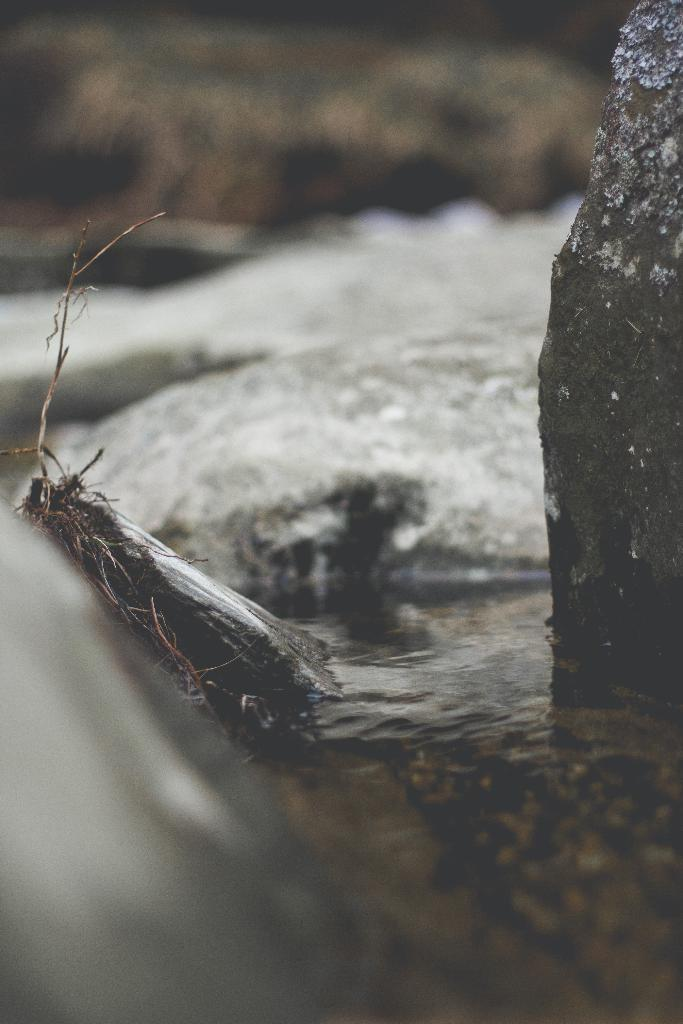What is present in the image that is not solid? There is water in the image. What solid object can be seen in the image? There is a rock in the image. Can you describe the quality of the top part of the image? The top part of the image is blurred. What type of lunch is being served on the roof in the image? There is no roof or lunch present in the image. Is there a boy visible in the image? There is no boy present in the image. 